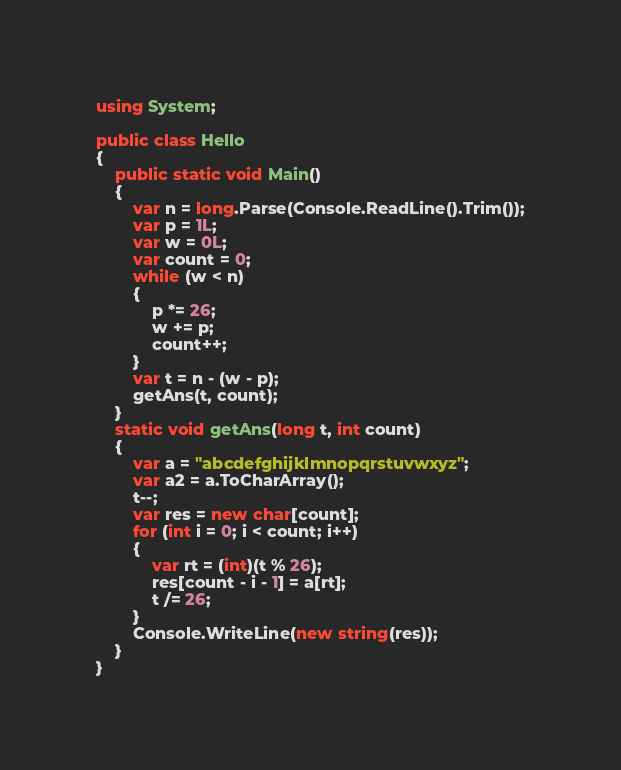Convert code to text. <code><loc_0><loc_0><loc_500><loc_500><_C#_>using System;

public class Hello
{
    public static void Main()
    {
        var n = long.Parse(Console.ReadLine().Trim());
        var p = 1L;
        var w = 0L;
        var count = 0;
        while (w < n)
        {
            p *= 26;
            w += p;
            count++;
        }
        var t = n - (w - p);
        getAns(t, count);
    }
    static void getAns(long t, int count)
    {
        var a = "abcdefghijklmnopqrstuvwxyz";
        var a2 = a.ToCharArray();
        t--;
        var res = new char[count];
        for (int i = 0; i < count; i++)
        {
            var rt = (int)(t % 26);
            res[count - i - 1] = a[rt];
            t /= 26;
        }
        Console.WriteLine(new string(res));
    }
}
</code> 